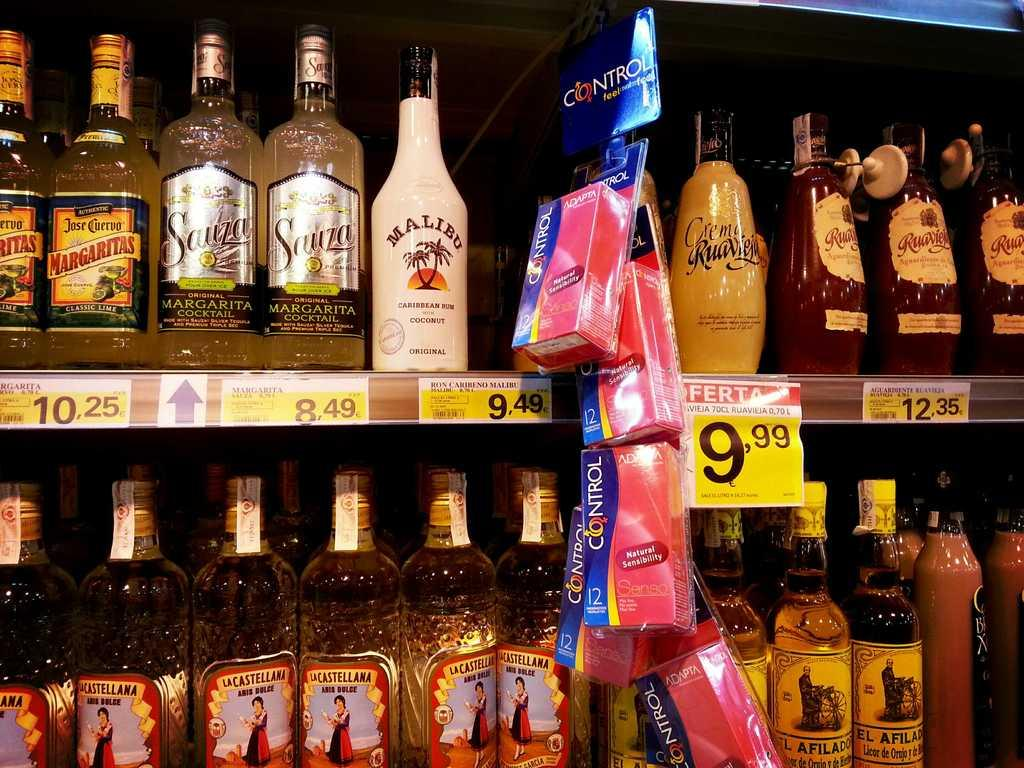<image>
Offer a succinct explanation of the picture presented. a group of bottles and the price which says 9.99 